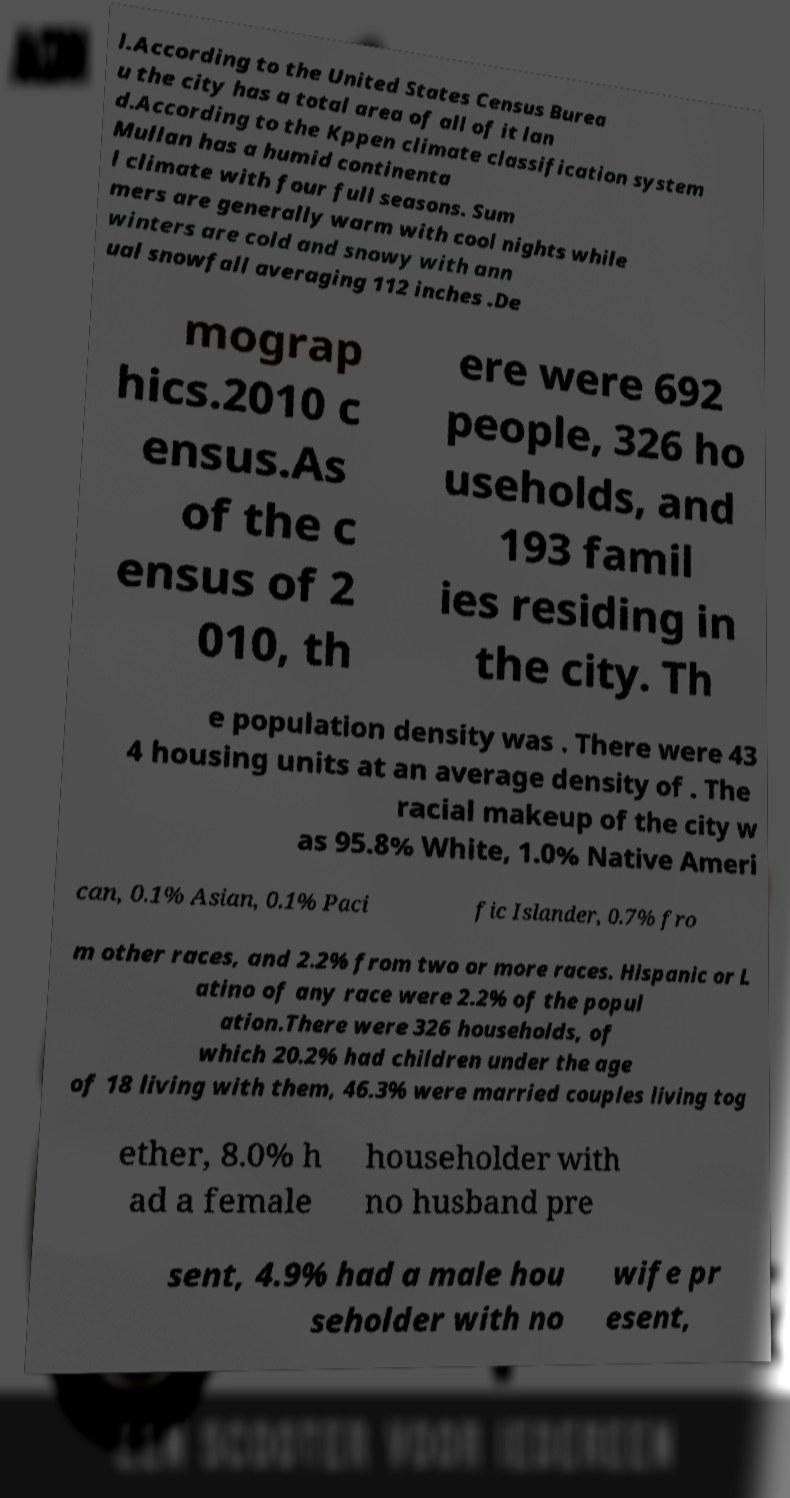Can you read and provide the text displayed in the image?This photo seems to have some interesting text. Can you extract and type it out for me? l.According to the United States Census Burea u the city has a total area of all of it lan d.According to the Kppen climate classification system Mullan has a humid continenta l climate with four full seasons. Sum mers are generally warm with cool nights while winters are cold and snowy with ann ual snowfall averaging 112 inches .De mograp hics.2010 c ensus.As of the c ensus of 2 010, th ere were 692 people, 326 ho useholds, and 193 famil ies residing in the city. Th e population density was . There were 43 4 housing units at an average density of . The racial makeup of the city w as 95.8% White, 1.0% Native Ameri can, 0.1% Asian, 0.1% Paci fic Islander, 0.7% fro m other races, and 2.2% from two or more races. Hispanic or L atino of any race were 2.2% of the popul ation.There were 326 households, of which 20.2% had children under the age of 18 living with them, 46.3% were married couples living tog ether, 8.0% h ad a female householder with no husband pre sent, 4.9% had a male hou seholder with no wife pr esent, 